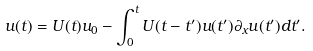Convert formula to latex. <formula><loc_0><loc_0><loc_500><loc_500>u ( t ) = U ( t ) u _ { 0 } - \int _ { 0 } ^ { t } U ( t - t ^ { \prime } ) u ( t ^ { \prime } ) \partial _ { x } u ( t ^ { \prime } ) d t ^ { \prime } .</formula> 